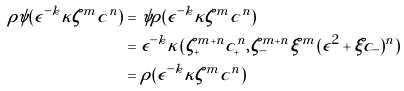<formula> <loc_0><loc_0><loc_500><loc_500>\rho \psi ( \epsilon ^ { - k } \kappa \zeta ^ { m } c ^ { n } ) & = \psi \rho ( \epsilon ^ { - k } \kappa \zeta ^ { m } c ^ { n } ) \\ & = \epsilon ^ { - k } \kappa ( \zeta _ { + } ^ { m + n } c _ { + } ^ { n } , \zeta _ { - } ^ { m + n } \xi ^ { m } ( \epsilon ^ { 2 } + \xi c _ { - } ) ^ { n } ) \\ & = \rho ( \epsilon ^ { - k } \kappa \zeta ^ { m } c ^ { n } )</formula> 